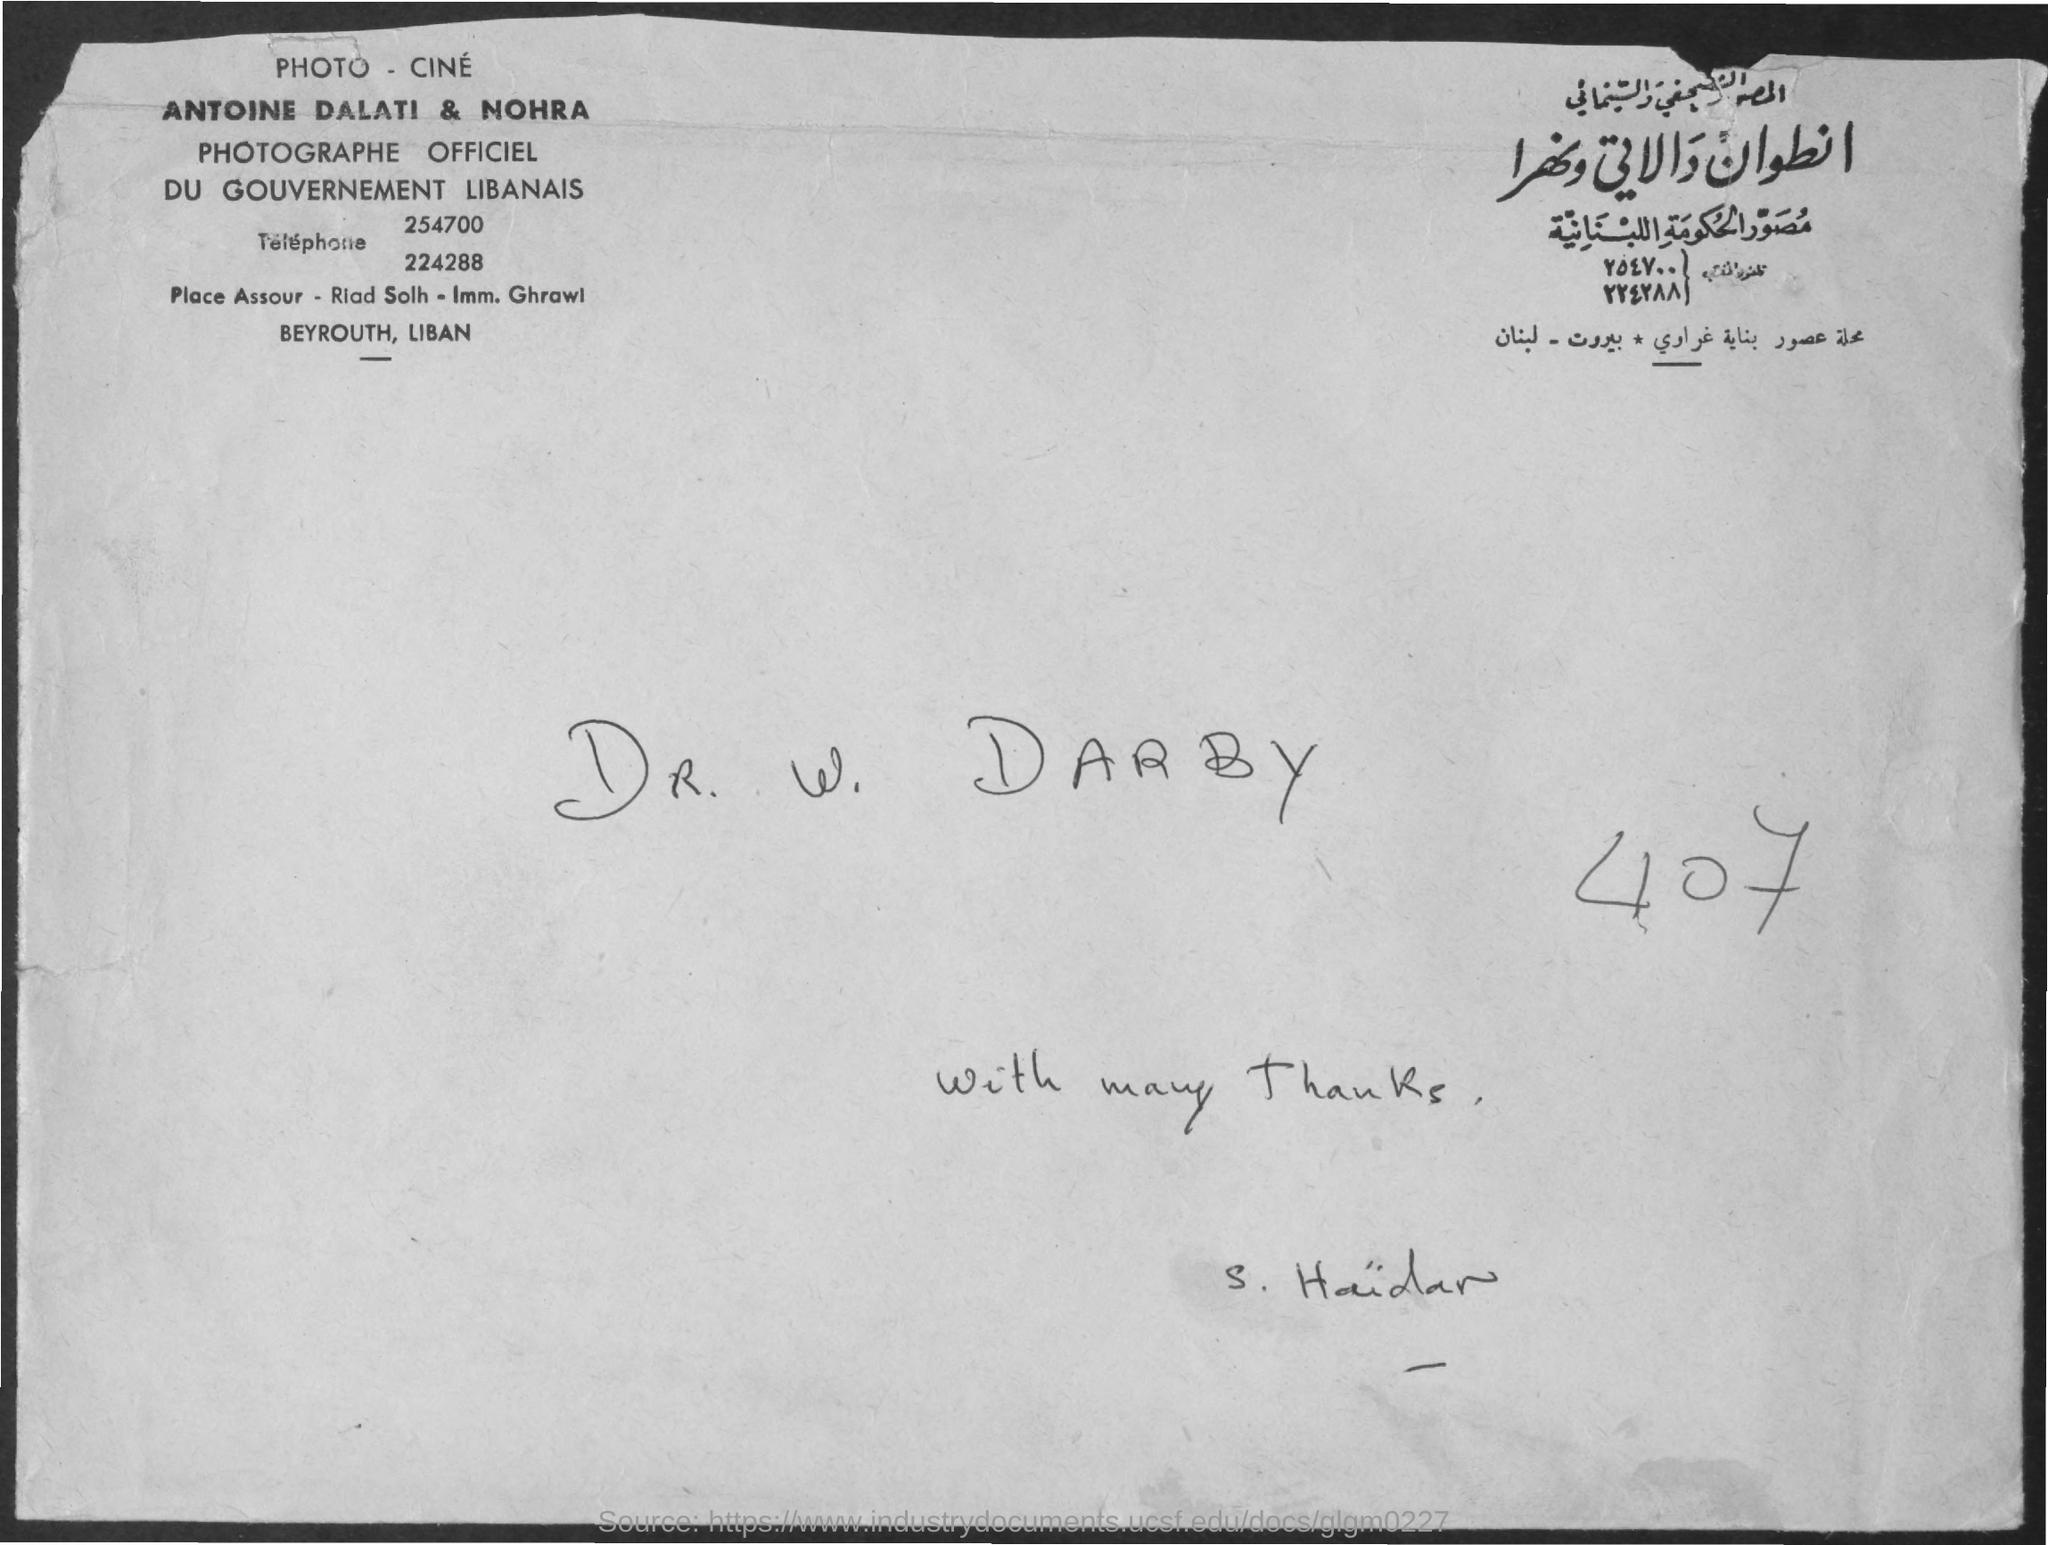Give some essential details in this illustration. Antoine Dalati and Nohra are the official photographers. The number mentioned in the document is 407.. 